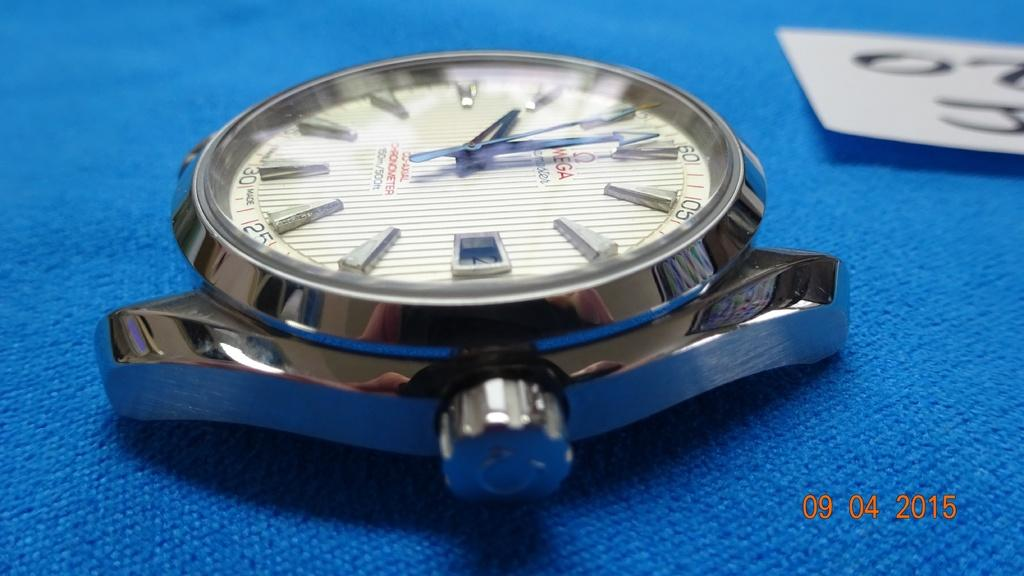Provide a one-sentence caption for the provided image. A Omega watch with no wrist band laying on a blue cloth. 